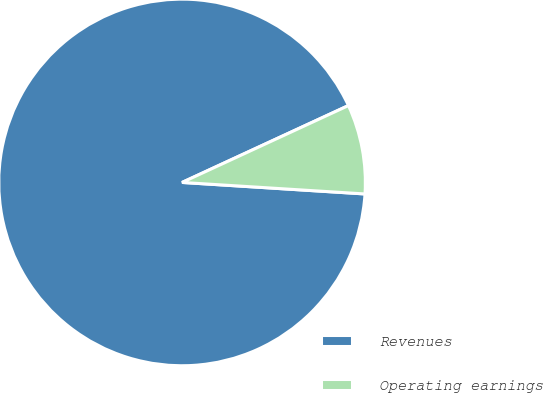Convert chart to OTSL. <chart><loc_0><loc_0><loc_500><loc_500><pie_chart><fcel>Revenues<fcel>Operating earnings<nl><fcel>92.11%<fcel>7.89%<nl></chart> 